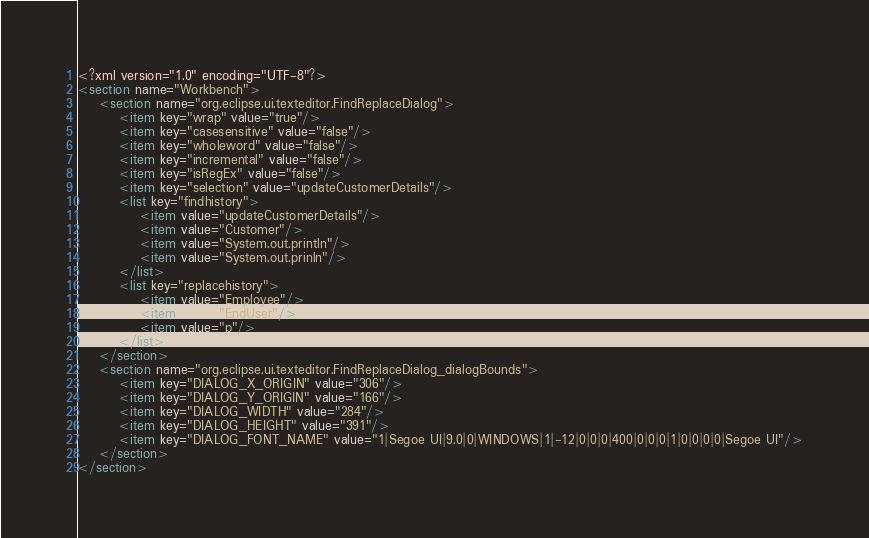Convert code to text. <code><loc_0><loc_0><loc_500><loc_500><_XML_><?xml version="1.0" encoding="UTF-8"?>
<section name="Workbench">
	<section name="org.eclipse.ui.texteditor.FindReplaceDialog">
		<item key="wrap" value="true"/>
		<item key="casesensitive" value="false"/>
		<item key="wholeword" value="false"/>
		<item key="incremental" value="false"/>
		<item key="isRegEx" value="false"/>
		<item key="selection" value="updateCustomerDetails"/>
		<list key="findhistory">
			<item value="updateCustomerDetails"/>
			<item value="Customer"/>
			<item value="System.out.println"/>
			<item value="System.out.prinln"/>
		</list>
		<list key="replacehistory">
			<item value="Employee"/>
			<item value="EndUser"/>
			<item value="p"/>
		</list>
	</section>
	<section name="org.eclipse.ui.texteditor.FindReplaceDialog_dialogBounds">
		<item key="DIALOG_X_ORIGIN" value="306"/>
		<item key="DIALOG_Y_ORIGIN" value="166"/>
		<item key="DIALOG_WIDTH" value="284"/>
		<item key="DIALOG_HEIGHT" value="391"/>
		<item key="DIALOG_FONT_NAME" value="1|Segoe UI|9.0|0|WINDOWS|1|-12|0|0|0|400|0|0|0|1|0|0|0|0|Segoe UI"/>
	</section>
</section>
</code> 